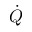<formula> <loc_0><loc_0><loc_500><loc_500>\dot { Q }</formula> 